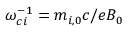Convert formula to latex. <formula><loc_0><loc_0><loc_500><loc_500>\omega _ { c i } ^ { - 1 } = m _ { i , 0 } c / e B _ { 0 }</formula> 